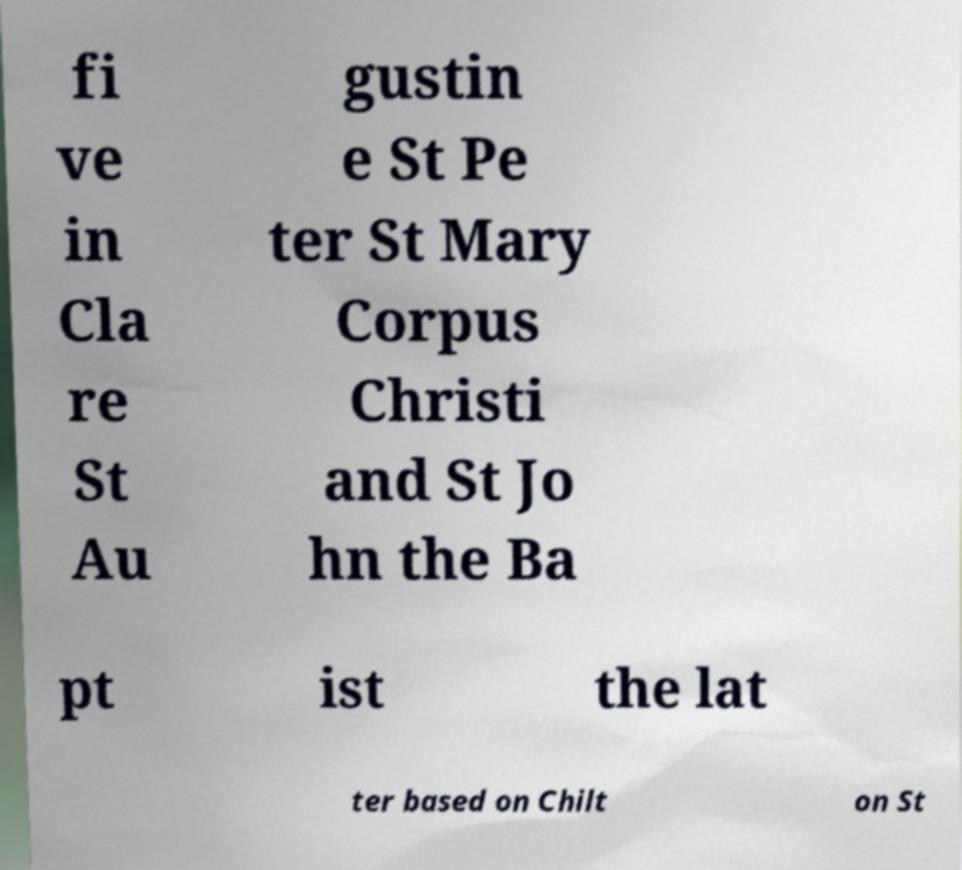Please read and relay the text visible in this image. What does it say? fi ve in Cla re St Au gustin e St Pe ter St Mary Corpus Christi and St Jo hn the Ba pt ist the lat ter based on Chilt on St 